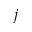<formula> <loc_0><loc_0><loc_500><loc_500>j</formula> 